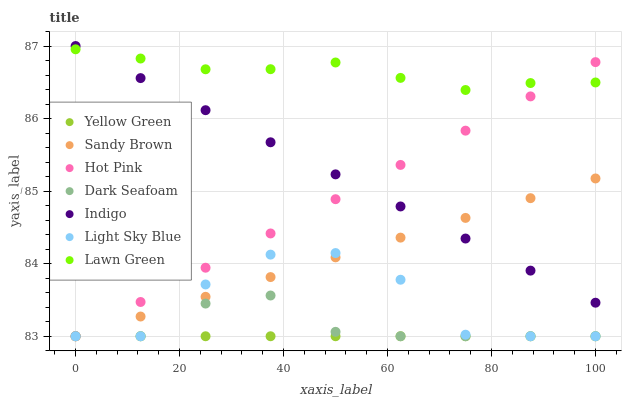Does Yellow Green have the minimum area under the curve?
Answer yes or no. Yes. Does Lawn Green have the maximum area under the curve?
Answer yes or no. Yes. Does Indigo have the minimum area under the curve?
Answer yes or no. No. Does Indigo have the maximum area under the curve?
Answer yes or no. No. Is Yellow Green the smoothest?
Answer yes or no. Yes. Is Light Sky Blue the roughest?
Answer yes or no. Yes. Is Indigo the smoothest?
Answer yes or no. No. Is Indigo the roughest?
Answer yes or no. No. Does Yellow Green have the lowest value?
Answer yes or no. Yes. Does Indigo have the lowest value?
Answer yes or no. No. Does Indigo have the highest value?
Answer yes or no. Yes. Does Yellow Green have the highest value?
Answer yes or no. No. Is Light Sky Blue less than Lawn Green?
Answer yes or no. Yes. Is Lawn Green greater than Dark Seafoam?
Answer yes or no. Yes. Does Indigo intersect Lawn Green?
Answer yes or no. Yes. Is Indigo less than Lawn Green?
Answer yes or no. No. Is Indigo greater than Lawn Green?
Answer yes or no. No. Does Light Sky Blue intersect Lawn Green?
Answer yes or no. No. 